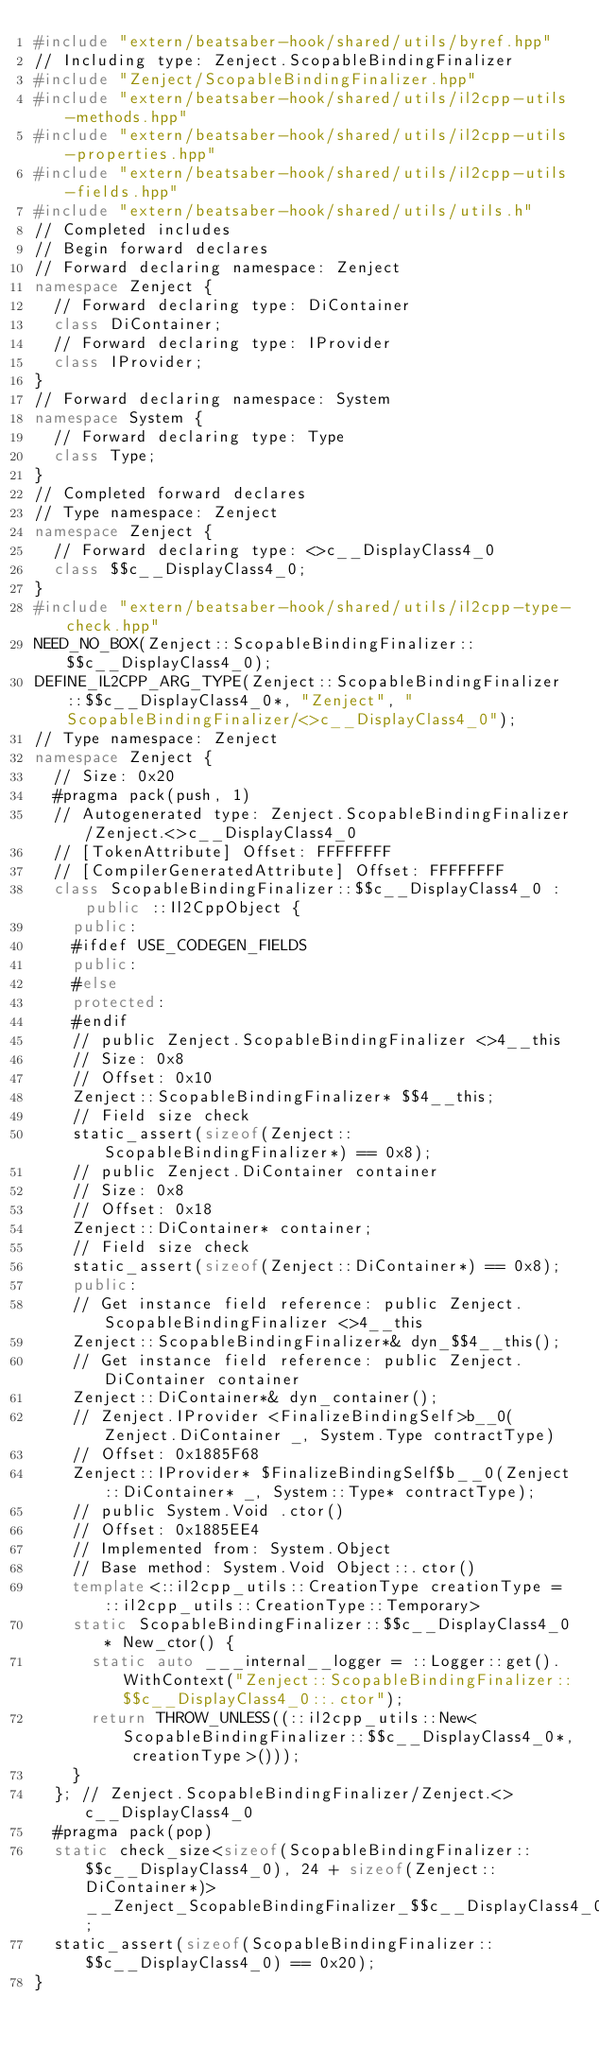Convert code to text. <code><loc_0><loc_0><loc_500><loc_500><_C++_>#include "extern/beatsaber-hook/shared/utils/byref.hpp"
// Including type: Zenject.ScopableBindingFinalizer
#include "Zenject/ScopableBindingFinalizer.hpp"
#include "extern/beatsaber-hook/shared/utils/il2cpp-utils-methods.hpp"
#include "extern/beatsaber-hook/shared/utils/il2cpp-utils-properties.hpp"
#include "extern/beatsaber-hook/shared/utils/il2cpp-utils-fields.hpp"
#include "extern/beatsaber-hook/shared/utils/utils.h"
// Completed includes
// Begin forward declares
// Forward declaring namespace: Zenject
namespace Zenject {
  // Forward declaring type: DiContainer
  class DiContainer;
  // Forward declaring type: IProvider
  class IProvider;
}
// Forward declaring namespace: System
namespace System {
  // Forward declaring type: Type
  class Type;
}
// Completed forward declares
// Type namespace: Zenject
namespace Zenject {
  // Forward declaring type: <>c__DisplayClass4_0
  class $$c__DisplayClass4_0;
}
#include "extern/beatsaber-hook/shared/utils/il2cpp-type-check.hpp"
NEED_NO_BOX(Zenject::ScopableBindingFinalizer::$$c__DisplayClass4_0);
DEFINE_IL2CPP_ARG_TYPE(Zenject::ScopableBindingFinalizer::$$c__DisplayClass4_0*, "Zenject", "ScopableBindingFinalizer/<>c__DisplayClass4_0");
// Type namespace: Zenject
namespace Zenject {
  // Size: 0x20
  #pragma pack(push, 1)
  // Autogenerated type: Zenject.ScopableBindingFinalizer/Zenject.<>c__DisplayClass4_0
  // [TokenAttribute] Offset: FFFFFFFF
  // [CompilerGeneratedAttribute] Offset: FFFFFFFF
  class ScopableBindingFinalizer::$$c__DisplayClass4_0 : public ::Il2CppObject {
    public:
    #ifdef USE_CODEGEN_FIELDS
    public:
    #else
    protected:
    #endif
    // public Zenject.ScopableBindingFinalizer <>4__this
    // Size: 0x8
    // Offset: 0x10
    Zenject::ScopableBindingFinalizer* $$4__this;
    // Field size check
    static_assert(sizeof(Zenject::ScopableBindingFinalizer*) == 0x8);
    // public Zenject.DiContainer container
    // Size: 0x8
    // Offset: 0x18
    Zenject::DiContainer* container;
    // Field size check
    static_assert(sizeof(Zenject::DiContainer*) == 0x8);
    public:
    // Get instance field reference: public Zenject.ScopableBindingFinalizer <>4__this
    Zenject::ScopableBindingFinalizer*& dyn_$$4__this();
    // Get instance field reference: public Zenject.DiContainer container
    Zenject::DiContainer*& dyn_container();
    // Zenject.IProvider <FinalizeBindingSelf>b__0(Zenject.DiContainer _, System.Type contractType)
    // Offset: 0x1885F68
    Zenject::IProvider* $FinalizeBindingSelf$b__0(Zenject::DiContainer* _, System::Type* contractType);
    // public System.Void .ctor()
    // Offset: 0x1885EE4
    // Implemented from: System.Object
    // Base method: System.Void Object::.ctor()
    template<::il2cpp_utils::CreationType creationType = ::il2cpp_utils::CreationType::Temporary>
    static ScopableBindingFinalizer::$$c__DisplayClass4_0* New_ctor() {
      static auto ___internal__logger = ::Logger::get().WithContext("Zenject::ScopableBindingFinalizer::$$c__DisplayClass4_0::.ctor");
      return THROW_UNLESS((::il2cpp_utils::New<ScopableBindingFinalizer::$$c__DisplayClass4_0*, creationType>()));
    }
  }; // Zenject.ScopableBindingFinalizer/Zenject.<>c__DisplayClass4_0
  #pragma pack(pop)
  static check_size<sizeof(ScopableBindingFinalizer::$$c__DisplayClass4_0), 24 + sizeof(Zenject::DiContainer*)> __Zenject_ScopableBindingFinalizer_$$c__DisplayClass4_0SizeCheck;
  static_assert(sizeof(ScopableBindingFinalizer::$$c__DisplayClass4_0) == 0x20);
}</code> 